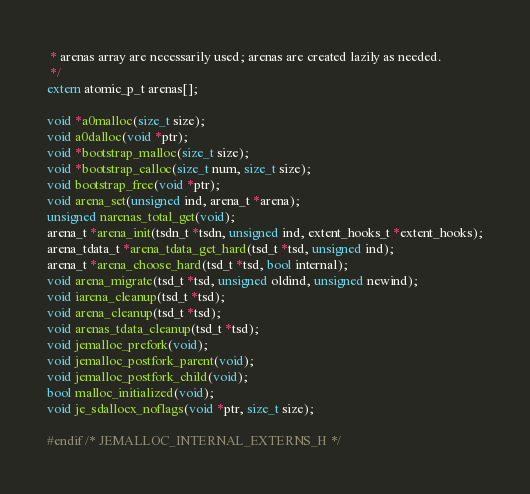<code> <loc_0><loc_0><loc_500><loc_500><_C_> * arenas array are necessarily used; arenas are created lazily as needed.
 */
extern atomic_p_t arenas[];

void *a0malloc(size_t size);
void a0dalloc(void *ptr);
void *bootstrap_malloc(size_t size);
void *bootstrap_calloc(size_t num, size_t size);
void bootstrap_free(void *ptr);
void arena_set(unsigned ind, arena_t *arena);
unsigned narenas_total_get(void);
arena_t *arena_init(tsdn_t *tsdn, unsigned ind, extent_hooks_t *extent_hooks);
arena_tdata_t *arena_tdata_get_hard(tsd_t *tsd, unsigned ind);
arena_t *arena_choose_hard(tsd_t *tsd, bool internal);
void arena_migrate(tsd_t *tsd, unsigned oldind, unsigned newind);
void iarena_cleanup(tsd_t *tsd);
void arena_cleanup(tsd_t *tsd);
void arenas_tdata_cleanup(tsd_t *tsd);
void jemalloc_prefork(void);
void jemalloc_postfork_parent(void);
void jemalloc_postfork_child(void);
bool malloc_initialized(void);
void je_sdallocx_noflags(void *ptr, size_t size);

#endif /* JEMALLOC_INTERNAL_EXTERNS_H */
</code> 